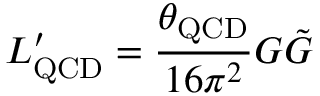<formula> <loc_0><loc_0><loc_500><loc_500>L _ { Q C D } ^ { \prime } = { \frac { \theta _ { Q C D } } { 1 6 \pi ^ { 2 } } } G \tilde { G }</formula> 